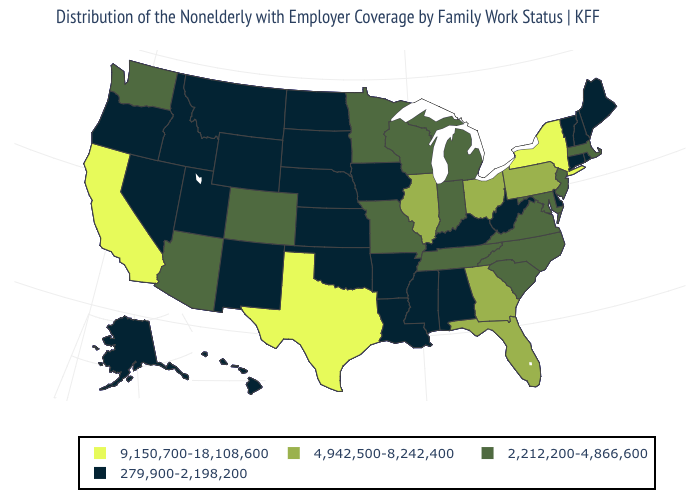Name the states that have a value in the range 279,900-2,198,200?
Short answer required. Alabama, Alaska, Arkansas, Connecticut, Delaware, Hawaii, Idaho, Iowa, Kansas, Kentucky, Louisiana, Maine, Mississippi, Montana, Nebraska, Nevada, New Hampshire, New Mexico, North Dakota, Oklahoma, Oregon, Rhode Island, South Dakota, Utah, Vermont, West Virginia, Wyoming. Name the states that have a value in the range 2,212,200-4,866,600?
Short answer required. Arizona, Colorado, Indiana, Maryland, Massachusetts, Michigan, Minnesota, Missouri, New Jersey, North Carolina, South Carolina, Tennessee, Virginia, Washington, Wisconsin. Name the states that have a value in the range 4,942,500-8,242,400?
Be succinct. Florida, Georgia, Illinois, Ohio, Pennsylvania. What is the highest value in the USA?
Give a very brief answer. 9,150,700-18,108,600. Which states have the highest value in the USA?
Short answer required. California, New York, Texas. How many symbols are there in the legend?
Be succinct. 4. Does the map have missing data?
Be succinct. No. Does Pennsylvania have the same value as Rhode Island?
Quick response, please. No. How many symbols are there in the legend?
Concise answer only. 4. What is the value of Hawaii?
Be succinct. 279,900-2,198,200. What is the value of Wisconsin?
Answer briefly. 2,212,200-4,866,600. Name the states that have a value in the range 9,150,700-18,108,600?
Write a very short answer. California, New York, Texas. What is the value of Arizona?
Short answer required. 2,212,200-4,866,600. What is the value of Washington?
Write a very short answer. 2,212,200-4,866,600. 